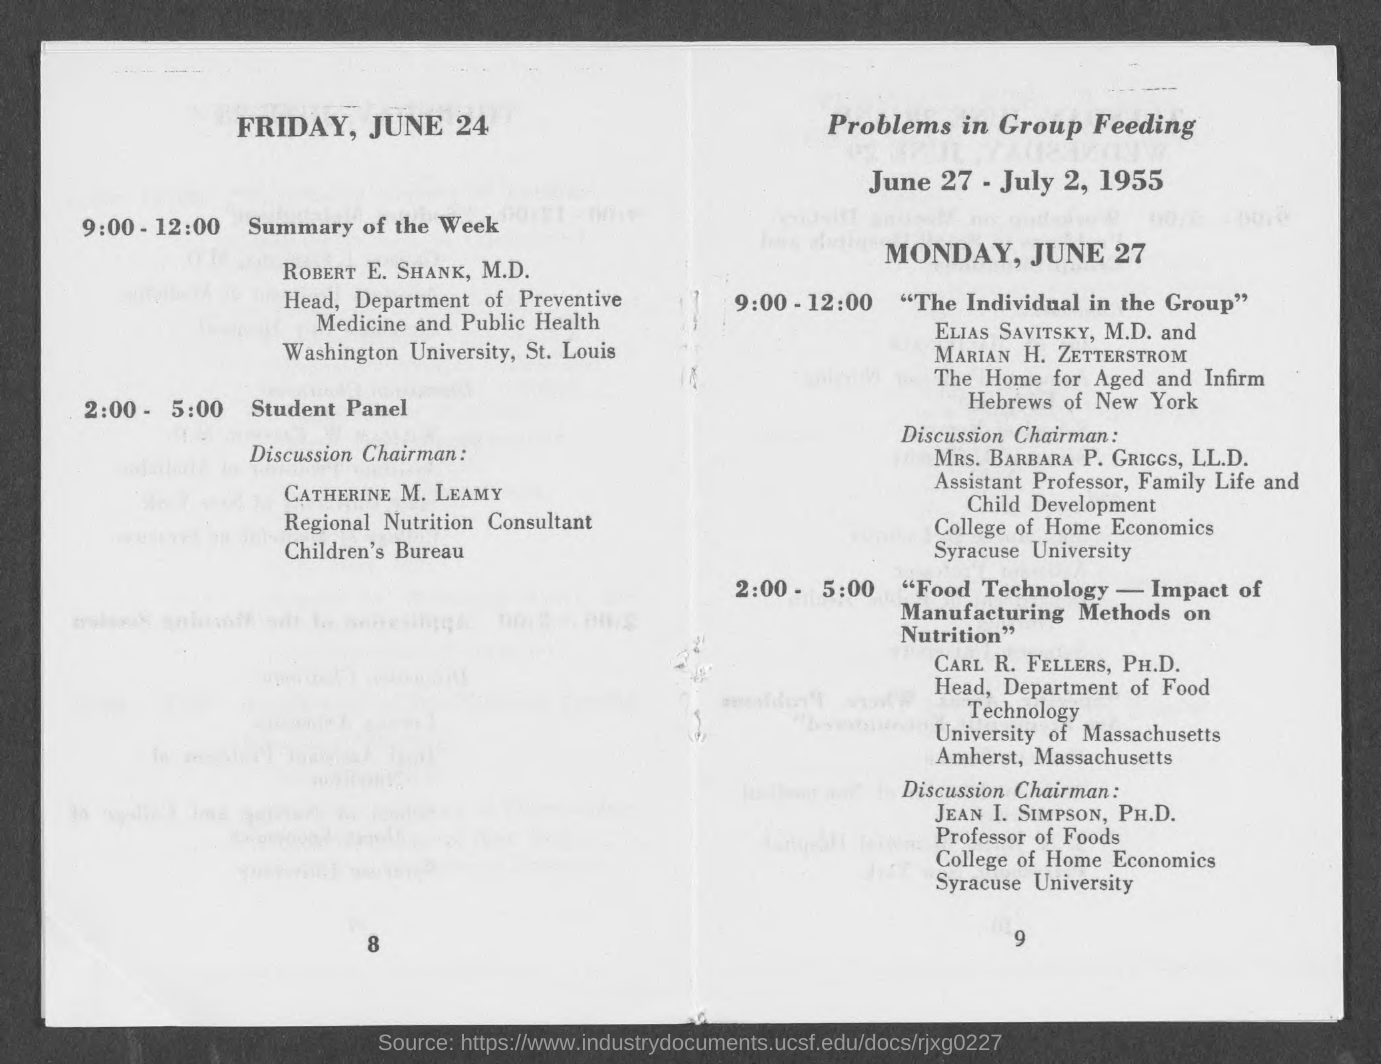Mention a couple of crucial points in this snapshot. The problem of group feeding was discussed from June 27 to July 2, 1955. 